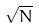Convert formula to latex. <formula><loc_0><loc_0><loc_500><loc_500>\sqrt { N }</formula> 